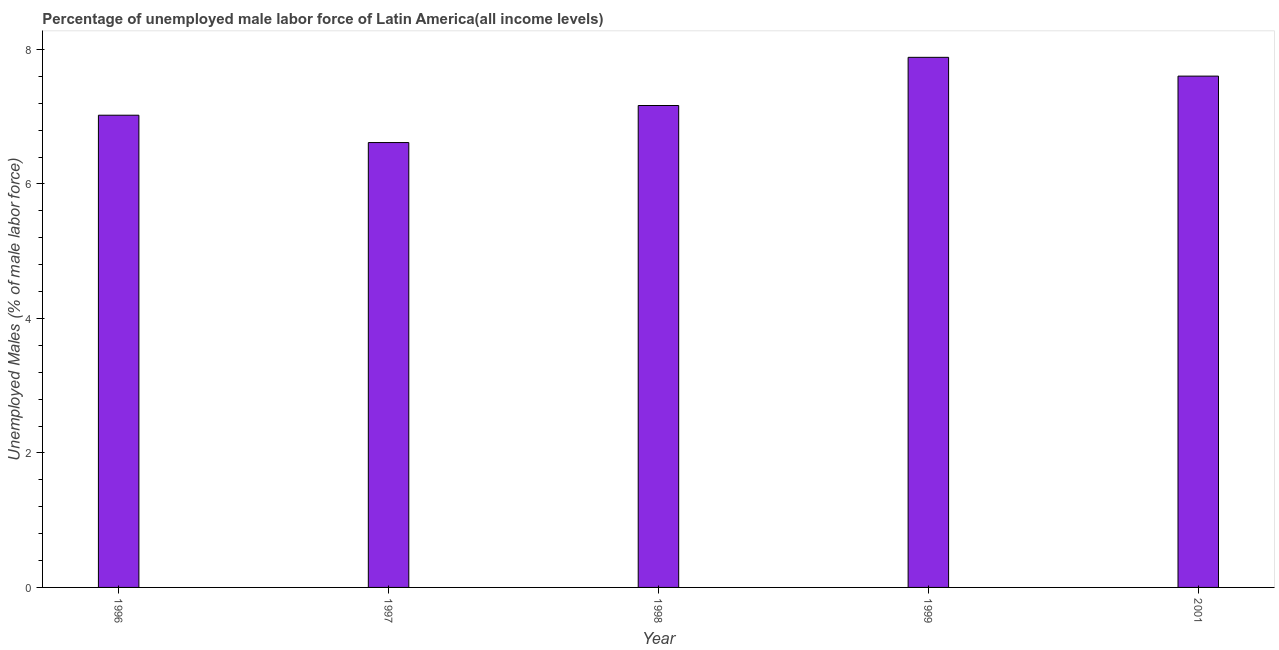Does the graph contain grids?
Give a very brief answer. No. What is the title of the graph?
Your answer should be very brief. Percentage of unemployed male labor force of Latin America(all income levels). What is the label or title of the Y-axis?
Offer a very short reply. Unemployed Males (% of male labor force). What is the total unemployed male labour force in 2001?
Your response must be concise. 7.6. Across all years, what is the maximum total unemployed male labour force?
Offer a very short reply. 7.88. Across all years, what is the minimum total unemployed male labour force?
Your answer should be very brief. 6.62. In which year was the total unemployed male labour force maximum?
Give a very brief answer. 1999. What is the sum of the total unemployed male labour force?
Your response must be concise. 36.29. What is the difference between the total unemployed male labour force in 1996 and 1999?
Give a very brief answer. -0.86. What is the average total unemployed male labour force per year?
Your answer should be compact. 7.26. What is the median total unemployed male labour force?
Keep it short and to the point. 7.17. Do a majority of the years between 2001 and 1996 (inclusive) have total unemployed male labour force greater than 5.2 %?
Give a very brief answer. Yes. What is the ratio of the total unemployed male labour force in 1997 to that in 1999?
Provide a short and direct response. 0.84. Is the difference between the total unemployed male labour force in 1997 and 1998 greater than the difference between any two years?
Provide a succinct answer. No. What is the difference between the highest and the second highest total unemployed male labour force?
Your answer should be very brief. 0.28. What is the difference between the highest and the lowest total unemployed male labour force?
Your answer should be compact. 1.27. Are all the bars in the graph horizontal?
Ensure brevity in your answer.  No. How many years are there in the graph?
Your answer should be very brief. 5. Are the values on the major ticks of Y-axis written in scientific E-notation?
Offer a terse response. No. What is the Unemployed Males (% of male labor force) in 1996?
Your answer should be very brief. 7.02. What is the Unemployed Males (% of male labor force) in 1997?
Give a very brief answer. 6.62. What is the Unemployed Males (% of male labor force) in 1998?
Keep it short and to the point. 7.17. What is the Unemployed Males (% of male labor force) in 1999?
Give a very brief answer. 7.88. What is the Unemployed Males (% of male labor force) of 2001?
Keep it short and to the point. 7.6. What is the difference between the Unemployed Males (% of male labor force) in 1996 and 1997?
Your answer should be very brief. 0.41. What is the difference between the Unemployed Males (% of male labor force) in 1996 and 1998?
Your response must be concise. -0.14. What is the difference between the Unemployed Males (% of male labor force) in 1996 and 1999?
Make the answer very short. -0.86. What is the difference between the Unemployed Males (% of male labor force) in 1996 and 2001?
Provide a short and direct response. -0.58. What is the difference between the Unemployed Males (% of male labor force) in 1997 and 1998?
Ensure brevity in your answer.  -0.55. What is the difference between the Unemployed Males (% of male labor force) in 1997 and 1999?
Provide a short and direct response. -1.27. What is the difference between the Unemployed Males (% of male labor force) in 1997 and 2001?
Make the answer very short. -0.99. What is the difference between the Unemployed Males (% of male labor force) in 1998 and 1999?
Make the answer very short. -0.72. What is the difference between the Unemployed Males (% of male labor force) in 1998 and 2001?
Your answer should be compact. -0.44. What is the difference between the Unemployed Males (% of male labor force) in 1999 and 2001?
Provide a short and direct response. 0.28. What is the ratio of the Unemployed Males (% of male labor force) in 1996 to that in 1997?
Your answer should be very brief. 1.06. What is the ratio of the Unemployed Males (% of male labor force) in 1996 to that in 1999?
Make the answer very short. 0.89. What is the ratio of the Unemployed Males (% of male labor force) in 1996 to that in 2001?
Your answer should be compact. 0.92. What is the ratio of the Unemployed Males (% of male labor force) in 1997 to that in 1998?
Give a very brief answer. 0.92. What is the ratio of the Unemployed Males (% of male labor force) in 1997 to that in 1999?
Ensure brevity in your answer.  0.84. What is the ratio of the Unemployed Males (% of male labor force) in 1997 to that in 2001?
Give a very brief answer. 0.87. What is the ratio of the Unemployed Males (% of male labor force) in 1998 to that in 1999?
Ensure brevity in your answer.  0.91. What is the ratio of the Unemployed Males (% of male labor force) in 1998 to that in 2001?
Offer a very short reply. 0.94. 